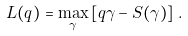<formula> <loc_0><loc_0><loc_500><loc_500>L ( q ) = \max _ { \gamma } \left [ q \gamma - S ( \gamma ) \right ] \, .</formula> 